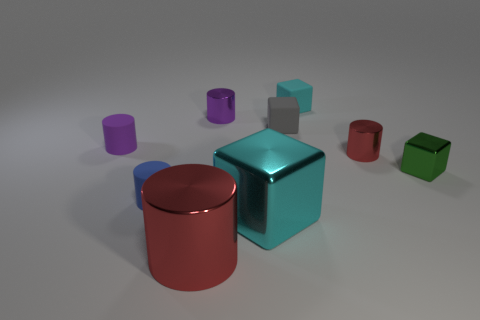Subtract 1 cylinders. How many cylinders are left? 4 Subtract all tiny purple metal cylinders. How many cylinders are left? 4 Subtract all blue cylinders. How many cylinders are left? 4 Subtract all yellow cylinders. Subtract all brown cubes. How many cylinders are left? 5 Add 1 big purple matte things. How many objects exist? 10 Subtract all blocks. How many objects are left? 5 Add 3 red metal things. How many red metal things are left? 5 Add 5 blue cylinders. How many blue cylinders exist? 6 Subtract 1 cyan cubes. How many objects are left? 8 Subtract all cyan objects. Subtract all red metal blocks. How many objects are left? 7 